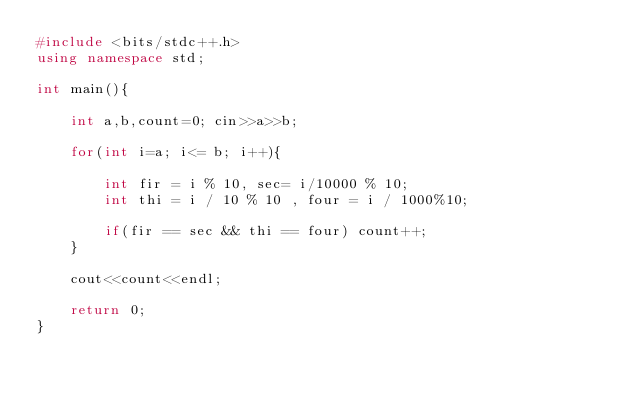<code> <loc_0><loc_0><loc_500><loc_500><_C++_>#include <bits/stdc++.h>
using namespace std;

int main(){

    int a,b,count=0; cin>>a>>b;

    for(int i=a; i<= b; i++){

        int fir = i % 10, sec= i/10000 % 10;
        int thi = i / 10 % 10 , four = i / 1000%10;

        if(fir == sec && thi == four) count++; 
    }

    cout<<count<<endl;

    return 0;
}</code> 